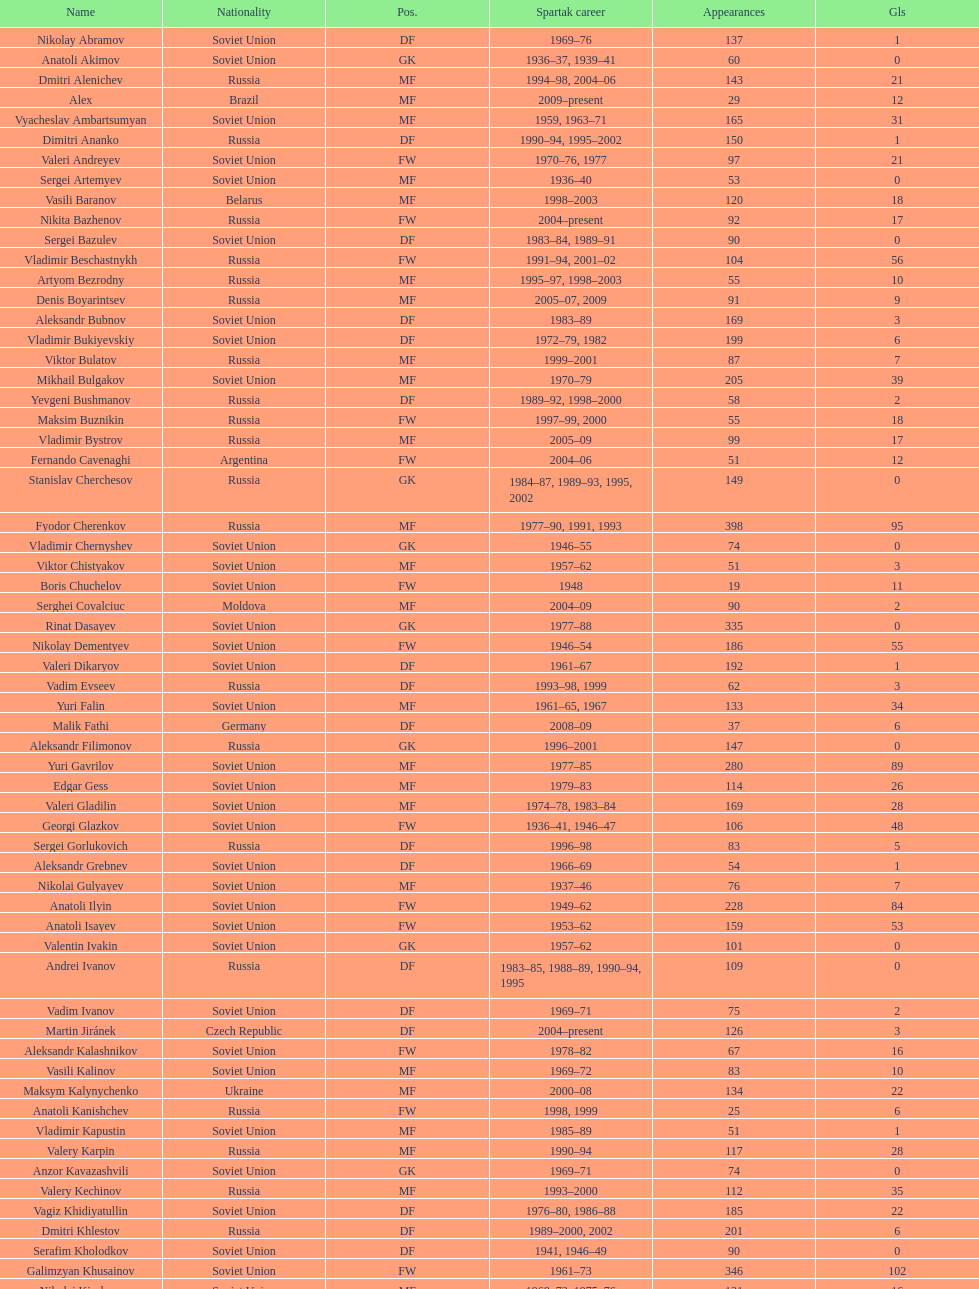Baranov has played from 2004 to the present. what is his nationality? Belarus. 